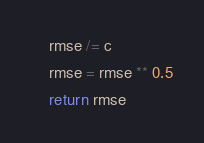<code> <loc_0><loc_0><loc_500><loc_500><_Python_>    rmse /= c
    rmse = rmse ** 0.5
    return rmse
</code> 